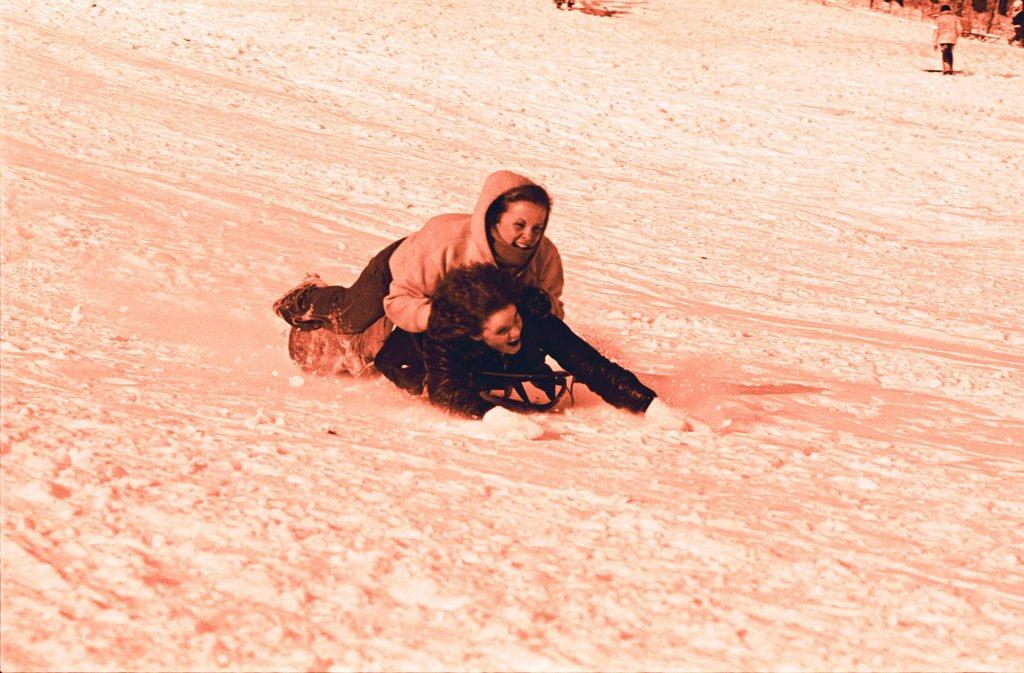How many people are in the image? There are two persons in the image. What is the person in the foreground wearing? The person in the foreground is wearing a black dress. Can you describe the other person in the image? There is another person standing in the background of the image. What is the name of the person with the snow-covered skin in the image? There is no person with snow-covered skin in the image, and therefore no name can be provided. 